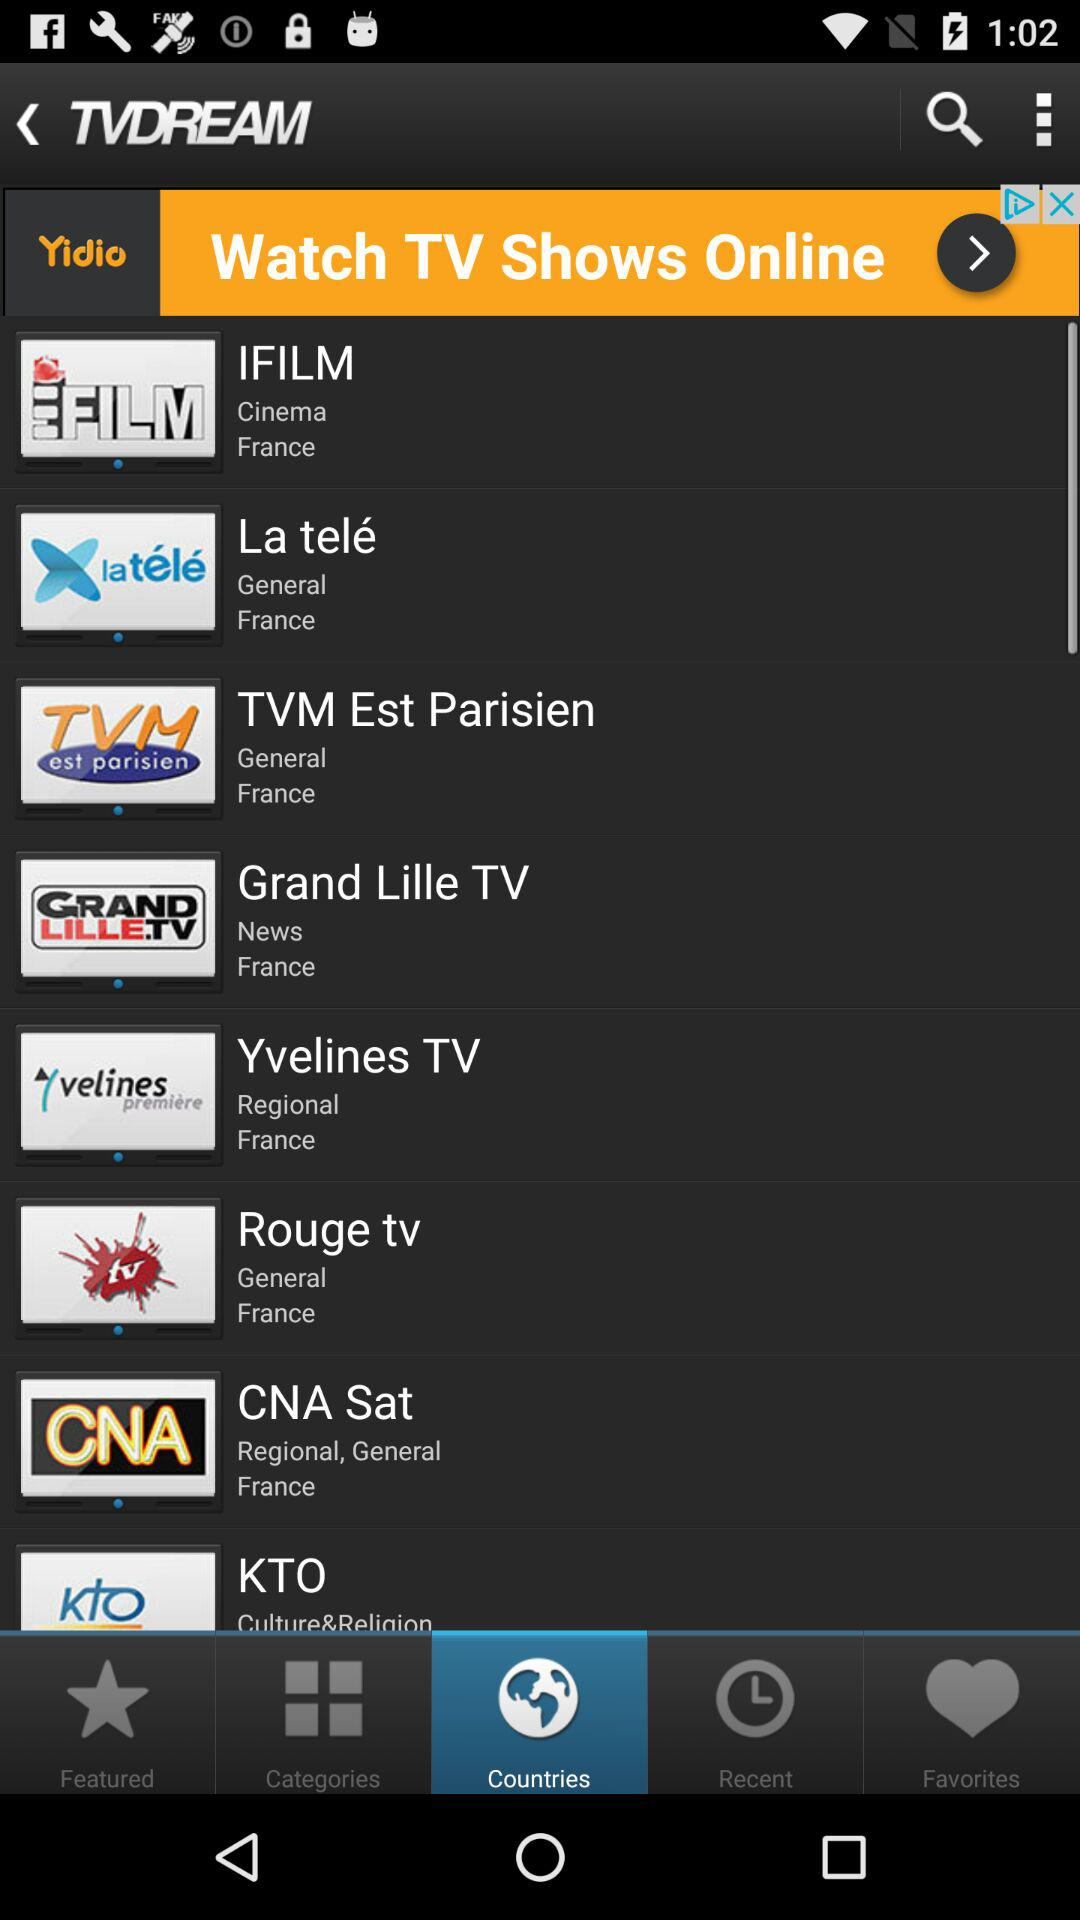What are the general channel names? The general channel names are "La telé", "TVM Est Parisien", "Rouge tv" and "CNA Sat". 